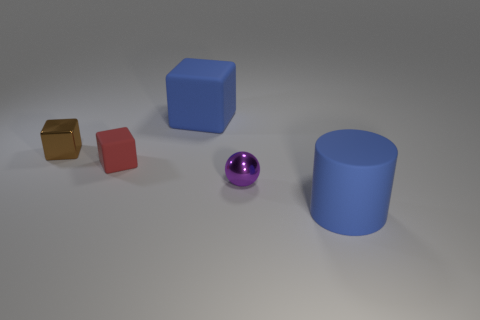Are there more brown shiny objects behind the large rubber cylinder than gray blocks?
Provide a short and direct response. Yes. What color is the matte object to the right of the large block?
Provide a succinct answer. Blue. Do the blue cube and the cylinder have the same size?
Offer a very short reply. Yes. The ball has what size?
Offer a terse response. Small. What shape is the big rubber thing that is the same color as the big cube?
Offer a very short reply. Cylinder. Are there more large blue cylinders than shiny cylinders?
Make the answer very short. Yes. There is a rubber object that is in front of the rubber thing left of the large thing behind the ball; what color is it?
Make the answer very short. Blue. Does the big blue thing left of the sphere have the same shape as the small red object?
Ensure brevity in your answer.  Yes. What color is the block that is the same size as the red thing?
Offer a very short reply. Brown. How many big shiny things are there?
Make the answer very short. 0. 